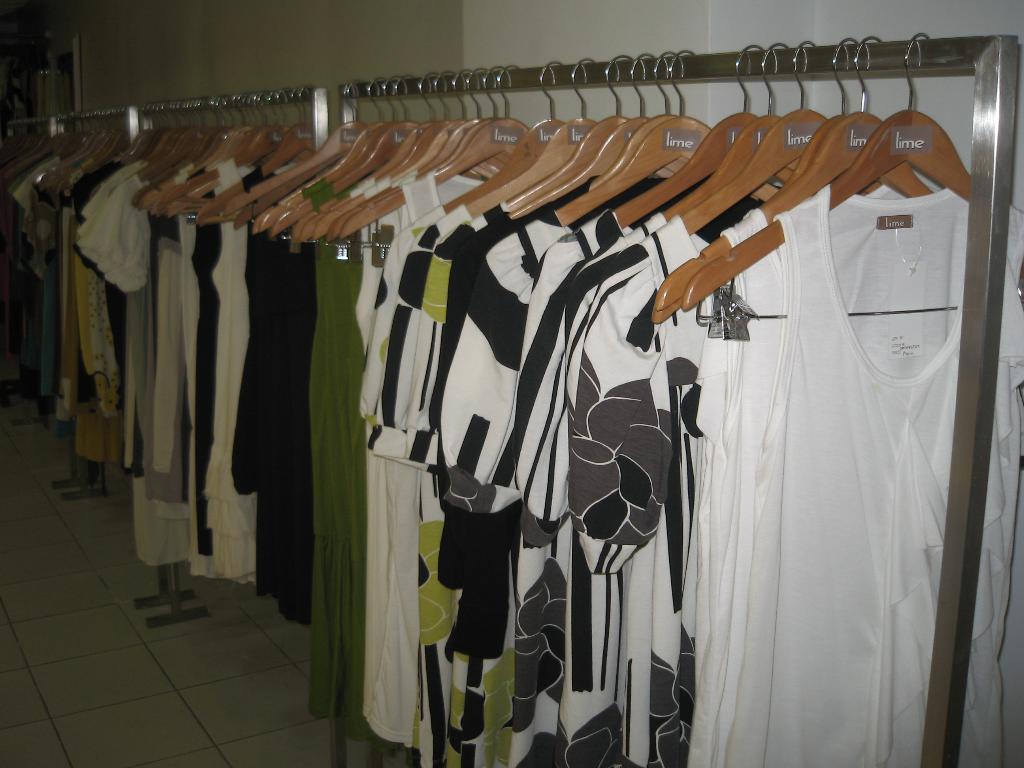In one or two sentences, can you explain what this image depicts? In the picture I can see clothes hanging to a metal rods. In the background I can see a wall. 